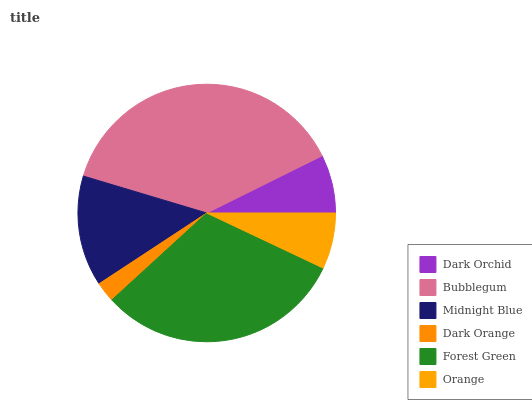Is Dark Orange the minimum?
Answer yes or no. Yes. Is Bubblegum the maximum?
Answer yes or no. Yes. Is Midnight Blue the minimum?
Answer yes or no. No. Is Midnight Blue the maximum?
Answer yes or no. No. Is Bubblegum greater than Midnight Blue?
Answer yes or no. Yes. Is Midnight Blue less than Bubblegum?
Answer yes or no. Yes. Is Midnight Blue greater than Bubblegum?
Answer yes or no. No. Is Bubblegum less than Midnight Blue?
Answer yes or no. No. Is Midnight Blue the high median?
Answer yes or no. Yes. Is Dark Orchid the low median?
Answer yes or no. Yes. Is Dark Orange the high median?
Answer yes or no. No. Is Forest Green the low median?
Answer yes or no. No. 